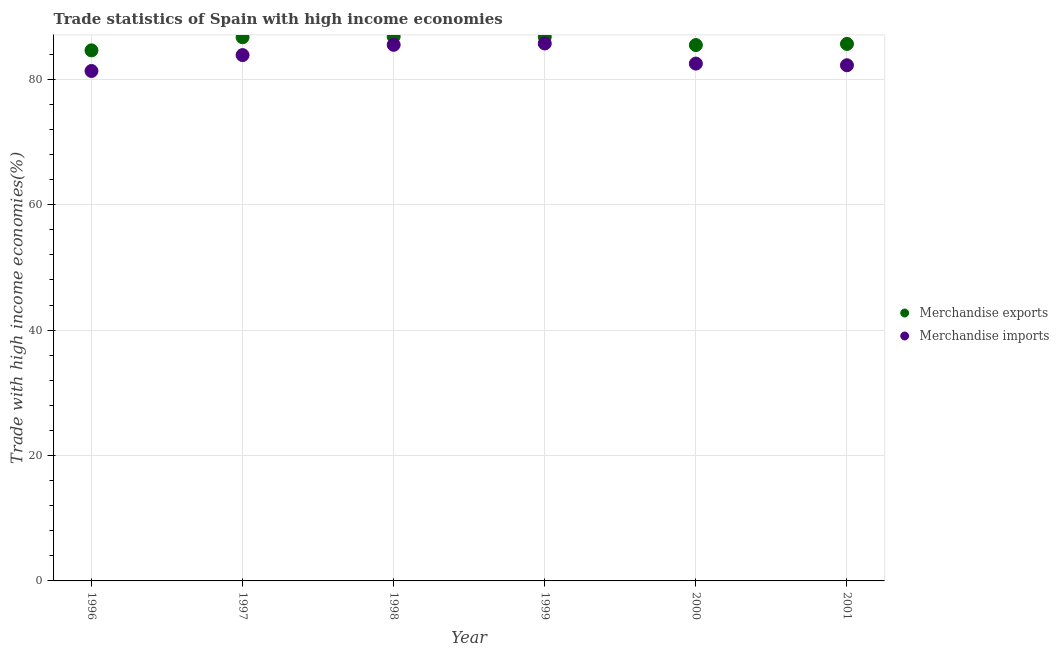What is the merchandise imports in 1999?
Offer a very short reply. 85.72. Across all years, what is the maximum merchandise exports?
Make the answer very short. 86.82. Across all years, what is the minimum merchandise exports?
Provide a succinct answer. 84.63. In which year was the merchandise imports maximum?
Provide a succinct answer. 1999. In which year was the merchandise exports minimum?
Give a very brief answer. 1996. What is the total merchandise exports in the graph?
Keep it short and to the point. 516.07. What is the difference between the merchandise imports in 2000 and that in 2001?
Your response must be concise. 0.27. What is the difference between the merchandise exports in 1997 and the merchandise imports in 1996?
Your answer should be very brief. 5.38. What is the average merchandise exports per year?
Give a very brief answer. 86.01. In the year 1996, what is the difference between the merchandise imports and merchandise exports?
Make the answer very short. -3.29. In how many years, is the merchandise exports greater than 52 %?
Your answer should be compact. 6. What is the ratio of the merchandise imports in 1996 to that in 1999?
Keep it short and to the point. 0.95. What is the difference between the highest and the second highest merchandise exports?
Your answer should be compact. 0.04. What is the difference between the highest and the lowest merchandise imports?
Your answer should be compact. 4.39. In how many years, is the merchandise exports greater than the average merchandise exports taken over all years?
Provide a short and direct response. 3. Is the merchandise imports strictly less than the merchandise exports over the years?
Offer a very short reply. Yes. How many dotlines are there?
Make the answer very short. 2. Does the graph contain grids?
Your answer should be very brief. Yes. How are the legend labels stacked?
Offer a terse response. Vertical. What is the title of the graph?
Make the answer very short. Trade statistics of Spain with high income economies. Does "Registered firms" appear as one of the legend labels in the graph?
Provide a succinct answer. No. What is the label or title of the Y-axis?
Your response must be concise. Trade with high income economies(%). What is the Trade with high income economies(%) of Merchandise exports in 1996?
Ensure brevity in your answer.  84.63. What is the Trade with high income economies(%) of Merchandise imports in 1996?
Provide a short and direct response. 81.33. What is the Trade with high income economies(%) of Merchandise exports in 1997?
Offer a very short reply. 86.72. What is the Trade with high income economies(%) of Merchandise imports in 1997?
Offer a terse response. 83.87. What is the Trade with high income economies(%) of Merchandise exports in 1998?
Offer a very short reply. 86.82. What is the Trade with high income economies(%) of Merchandise imports in 1998?
Ensure brevity in your answer.  85.51. What is the Trade with high income economies(%) of Merchandise exports in 1999?
Your response must be concise. 86.78. What is the Trade with high income economies(%) in Merchandise imports in 1999?
Keep it short and to the point. 85.72. What is the Trade with high income economies(%) of Merchandise exports in 2000?
Provide a short and direct response. 85.47. What is the Trade with high income economies(%) in Merchandise imports in 2000?
Offer a terse response. 82.52. What is the Trade with high income economies(%) in Merchandise exports in 2001?
Your answer should be very brief. 85.65. What is the Trade with high income economies(%) in Merchandise imports in 2001?
Provide a succinct answer. 82.25. Across all years, what is the maximum Trade with high income economies(%) in Merchandise exports?
Provide a short and direct response. 86.82. Across all years, what is the maximum Trade with high income economies(%) of Merchandise imports?
Your response must be concise. 85.72. Across all years, what is the minimum Trade with high income economies(%) in Merchandise exports?
Your answer should be compact. 84.63. Across all years, what is the minimum Trade with high income economies(%) in Merchandise imports?
Keep it short and to the point. 81.33. What is the total Trade with high income economies(%) in Merchandise exports in the graph?
Provide a succinct answer. 516.07. What is the total Trade with high income economies(%) of Merchandise imports in the graph?
Keep it short and to the point. 501.2. What is the difference between the Trade with high income economies(%) in Merchandise exports in 1996 and that in 1997?
Give a very brief answer. -2.09. What is the difference between the Trade with high income economies(%) of Merchandise imports in 1996 and that in 1997?
Ensure brevity in your answer.  -2.54. What is the difference between the Trade with high income economies(%) in Merchandise exports in 1996 and that in 1998?
Provide a succinct answer. -2.2. What is the difference between the Trade with high income economies(%) of Merchandise imports in 1996 and that in 1998?
Give a very brief answer. -4.18. What is the difference between the Trade with high income economies(%) of Merchandise exports in 1996 and that in 1999?
Ensure brevity in your answer.  -2.16. What is the difference between the Trade with high income economies(%) of Merchandise imports in 1996 and that in 1999?
Keep it short and to the point. -4.39. What is the difference between the Trade with high income economies(%) in Merchandise exports in 1996 and that in 2000?
Keep it short and to the point. -0.84. What is the difference between the Trade with high income economies(%) of Merchandise imports in 1996 and that in 2000?
Your answer should be very brief. -1.18. What is the difference between the Trade with high income economies(%) in Merchandise exports in 1996 and that in 2001?
Ensure brevity in your answer.  -1.03. What is the difference between the Trade with high income economies(%) of Merchandise imports in 1996 and that in 2001?
Give a very brief answer. -0.92. What is the difference between the Trade with high income economies(%) of Merchandise exports in 1997 and that in 1998?
Your answer should be compact. -0.1. What is the difference between the Trade with high income economies(%) in Merchandise imports in 1997 and that in 1998?
Keep it short and to the point. -1.64. What is the difference between the Trade with high income economies(%) in Merchandise exports in 1997 and that in 1999?
Make the answer very short. -0.06. What is the difference between the Trade with high income economies(%) of Merchandise imports in 1997 and that in 1999?
Your answer should be compact. -1.85. What is the difference between the Trade with high income economies(%) in Merchandise exports in 1997 and that in 2000?
Provide a succinct answer. 1.25. What is the difference between the Trade with high income economies(%) of Merchandise imports in 1997 and that in 2000?
Offer a very short reply. 1.36. What is the difference between the Trade with high income economies(%) in Merchandise exports in 1997 and that in 2001?
Give a very brief answer. 1.07. What is the difference between the Trade with high income economies(%) of Merchandise imports in 1997 and that in 2001?
Your answer should be compact. 1.62. What is the difference between the Trade with high income economies(%) in Merchandise exports in 1998 and that in 1999?
Keep it short and to the point. 0.04. What is the difference between the Trade with high income economies(%) in Merchandise imports in 1998 and that in 1999?
Offer a very short reply. -0.21. What is the difference between the Trade with high income economies(%) of Merchandise exports in 1998 and that in 2000?
Your answer should be very brief. 1.35. What is the difference between the Trade with high income economies(%) of Merchandise imports in 1998 and that in 2000?
Offer a terse response. 2.99. What is the difference between the Trade with high income economies(%) of Merchandise exports in 1998 and that in 2001?
Make the answer very short. 1.17. What is the difference between the Trade with high income economies(%) of Merchandise imports in 1998 and that in 2001?
Make the answer very short. 3.26. What is the difference between the Trade with high income economies(%) in Merchandise exports in 1999 and that in 2000?
Your answer should be very brief. 1.31. What is the difference between the Trade with high income economies(%) of Merchandise imports in 1999 and that in 2000?
Keep it short and to the point. 3.21. What is the difference between the Trade with high income economies(%) of Merchandise exports in 1999 and that in 2001?
Provide a short and direct response. 1.13. What is the difference between the Trade with high income economies(%) in Merchandise imports in 1999 and that in 2001?
Your response must be concise. 3.47. What is the difference between the Trade with high income economies(%) of Merchandise exports in 2000 and that in 2001?
Offer a terse response. -0.18. What is the difference between the Trade with high income economies(%) in Merchandise imports in 2000 and that in 2001?
Your response must be concise. 0.27. What is the difference between the Trade with high income economies(%) in Merchandise exports in 1996 and the Trade with high income economies(%) in Merchandise imports in 1997?
Your answer should be very brief. 0.75. What is the difference between the Trade with high income economies(%) in Merchandise exports in 1996 and the Trade with high income economies(%) in Merchandise imports in 1998?
Keep it short and to the point. -0.88. What is the difference between the Trade with high income economies(%) of Merchandise exports in 1996 and the Trade with high income economies(%) of Merchandise imports in 1999?
Make the answer very short. -1.1. What is the difference between the Trade with high income economies(%) of Merchandise exports in 1996 and the Trade with high income economies(%) of Merchandise imports in 2000?
Ensure brevity in your answer.  2.11. What is the difference between the Trade with high income economies(%) in Merchandise exports in 1996 and the Trade with high income economies(%) in Merchandise imports in 2001?
Provide a short and direct response. 2.38. What is the difference between the Trade with high income economies(%) of Merchandise exports in 1997 and the Trade with high income economies(%) of Merchandise imports in 1998?
Offer a very short reply. 1.21. What is the difference between the Trade with high income economies(%) in Merchandise exports in 1997 and the Trade with high income economies(%) in Merchandise imports in 2000?
Your response must be concise. 4.2. What is the difference between the Trade with high income economies(%) in Merchandise exports in 1997 and the Trade with high income economies(%) in Merchandise imports in 2001?
Give a very brief answer. 4.47. What is the difference between the Trade with high income economies(%) in Merchandise exports in 1998 and the Trade with high income economies(%) in Merchandise imports in 1999?
Offer a terse response. 1.1. What is the difference between the Trade with high income economies(%) in Merchandise exports in 1998 and the Trade with high income economies(%) in Merchandise imports in 2000?
Your response must be concise. 4.31. What is the difference between the Trade with high income economies(%) in Merchandise exports in 1998 and the Trade with high income economies(%) in Merchandise imports in 2001?
Your answer should be compact. 4.57. What is the difference between the Trade with high income economies(%) of Merchandise exports in 1999 and the Trade with high income economies(%) of Merchandise imports in 2000?
Keep it short and to the point. 4.27. What is the difference between the Trade with high income economies(%) in Merchandise exports in 1999 and the Trade with high income economies(%) in Merchandise imports in 2001?
Offer a very short reply. 4.53. What is the difference between the Trade with high income economies(%) in Merchandise exports in 2000 and the Trade with high income economies(%) in Merchandise imports in 2001?
Give a very brief answer. 3.22. What is the average Trade with high income economies(%) in Merchandise exports per year?
Your answer should be very brief. 86.01. What is the average Trade with high income economies(%) in Merchandise imports per year?
Offer a terse response. 83.53. In the year 1996, what is the difference between the Trade with high income economies(%) of Merchandise exports and Trade with high income economies(%) of Merchandise imports?
Give a very brief answer. 3.29. In the year 1997, what is the difference between the Trade with high income economies(%) of Merchandise exports and Trade with high income economies(%) of Merchandise imports?
Keep it short and to the point. 2.85. In the year 1998, what is the difference between the Trade with high income economies(%) in Merchandise exports and Trade with high income economies(%) in Merchandise imports?
Make the answer very short. 1.31. In the year 1999, what is the difference between the Trade with high income economies(%) of Merchandise exports and Trade with high income economies(%) of Merchandise imports?
Your response must be concise. 1.06. In the year 2000, what is the difference between the Trade with high income economies(%) of Merchandise exports and Trade with high income economies(%) of Merchandise imports?
Your answer should be very brief. 2.96. In the year 2001, what is the difference between the Trade with high income economies(%) of Merchandise exports and Trade with high income economies(%) of Merchandise imports?
Make the answer very short. 3.4. What is the ratio of the Trade with high income economies(%) in Merchandise exports in 1996 to that in 1997?
Keep it short and to the point. 0.98. What is the ratio of the Trade with high income economies(%) of Merchandise imports in 1996 to that in 1997?
Make the answer very short. 0.97. What is the ratio of the Trade with high income economies(%) in Merchandise exports in 1996 to that in 1998?
Offer a terse response. 0.97. What is the ratio of the Trade with high income economies(%) of Merchandise imports in 1996 to that in 1998?
Your answer should be very brief. 0.95. What is the ratio of the Trade with high income economies(%) of Merchandise exports in 1996 to that in 1999?
Your answer should be very brief. 0.98. What is the ratio of the Trade with high income economies(%) of Merchandise imports in 1996 to that in 1999?
Make the answer very short. 0.95. What is the ratio of the Trade with high income economies(%) of Merchandise exports in 1996 to that in 2000?
Keep it short and to the point. 0.99. What is the ratio of the Trade with high income economies(%) of Merchandise imports in 1996 to that in 2000?
Offer a very short reply. 0.99. What is the ratio of the Trade with high income economies(%) of Merchandise imports in 1996 to that in 2001?
Make the answer very short. 0.99. What is the ratio of the Trade with high income economies(%) of Merchandise exports in 1997 to that in 1998?
Keep it short and to the point. 1. What is the ratio of the Trade with high income economies(%) of Merchandise imports in 1997 to that in 1998?
Give a very brief answer. 0.98. What is the ratio of the Trade with high income economies(%) in Merchandise imports in 1997 to that in 1999?
Make the answer very short. 0.98. What is the ratio of the Trade with high income economies(%) in Merchandise exports in 1997 to that in 2000?
Ensure brevity in your answer.  1.01. What is the ratio of the Trade with high income economies(%) in Merchandise imports in 1997 to that in 2000?
Give a very brief answer. 1.02. What is the ratio of the Trade with high income economies(%) of Merchandise exports in 1997 to that in 2001?
Give a very brief answer. 1.01. What is the ratio of the Trade with high income economies(%) in Merchandise imports in 1997 to that in 2001?
Your answer should be compact. 1.02. What is the ratio of the Trade with high income economies(%) in Merchandise exports in 1998 to that in 1999?
Keep it short and to the point. 1. What is the ratio of the Trade with high income economies(%) in Merchandise exports in 1998 to that in 2000?
Offer a very short reply. 1.02. What is the ratio of the Trade with high income economies(%) in Merchandise imports in 1998 to that in 2000?
Keep it short and to the point. 1.04. What is the ratio of the Trade with high income economies(%) of Merchandise exports in 1998 to that in 2001?
Ensure brevity in your answer.  1.01. What is the ratio of the Trade with high income economies(%) of Merchandise imports in 1998 to that in 2001?
Offer a terse response. 1.04. What is the ratio of the Trade with high income economies(%) in Merchandise exports in 1999 to that in 2000?
Ensure brevity in your answer.  1.02. What is the ratio of the Trade with high income economies(%) in Merchandise imports in 1999 to that in 2000?
Make the answer very short. 1.04. What is the ratio of the Trade with high income economies(%) of Merchandise exports in 1999 to that in 2001?
Offer a very short reply. 1.01. What is the ratio of the Trade with high income economies(%) in Merchandise imports in 1999 to that in 2001?
Offer a terse response. 1.04. What is the ratio of the Trade with high income economies(%) in Merchandise imports in 2000 to that in 2001?
Give a very brief answer. 1. What is the difference between the highest and the second highest Trade with high income economies(%) of Merchandise exports?
Make the answer very short. 0.04. What is the difference between the highest and the second highest Trade with high income economies(%) of Merchandise imports?
Keep it short and to the point. 0.21. What is the difference between the highest and the lowest Trade with high income economies(%) in Merchandise exports?
Give a very brief answer. 2.2. What is the difference between the highest and the lowest Trade with high income economies(%) in Merchandise imports?
Keep it short and to the point. 4.39. 